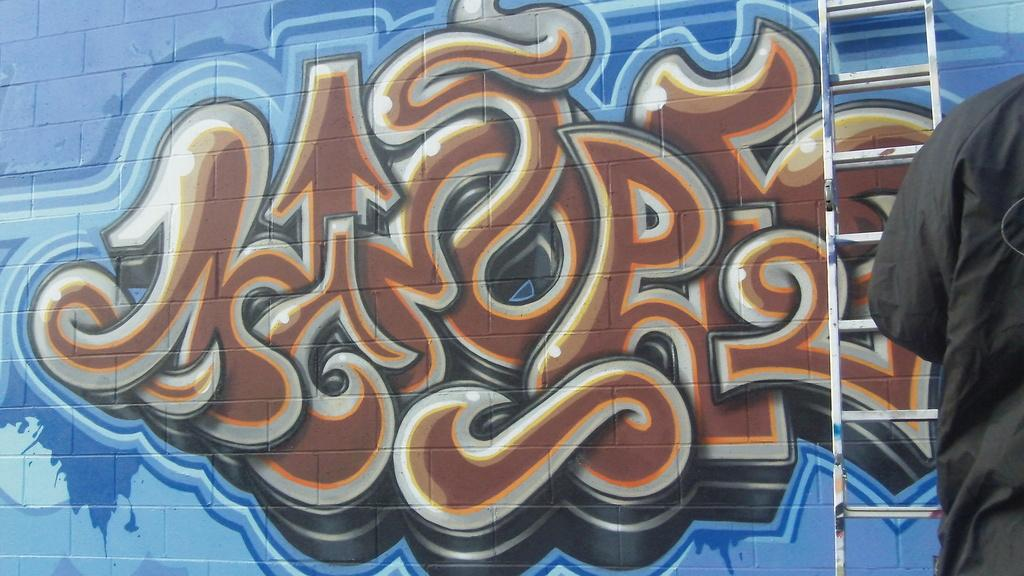What is displayed on the wall in the image? There is an art piece on the wall in the image. What object can be seen in the image that might be used for reaching high places? There is a ladder in the image. Can you describe the presence of a person in the image? A part of a person is visible on the right side of the image. What type of print can be seen on the person's chin in the image? There is no person's chin visible in the image, and therefore no print can be observed. How many birds are present in the flock on the art piece in the image? There is no flock of birds present on the art piece in the image. 